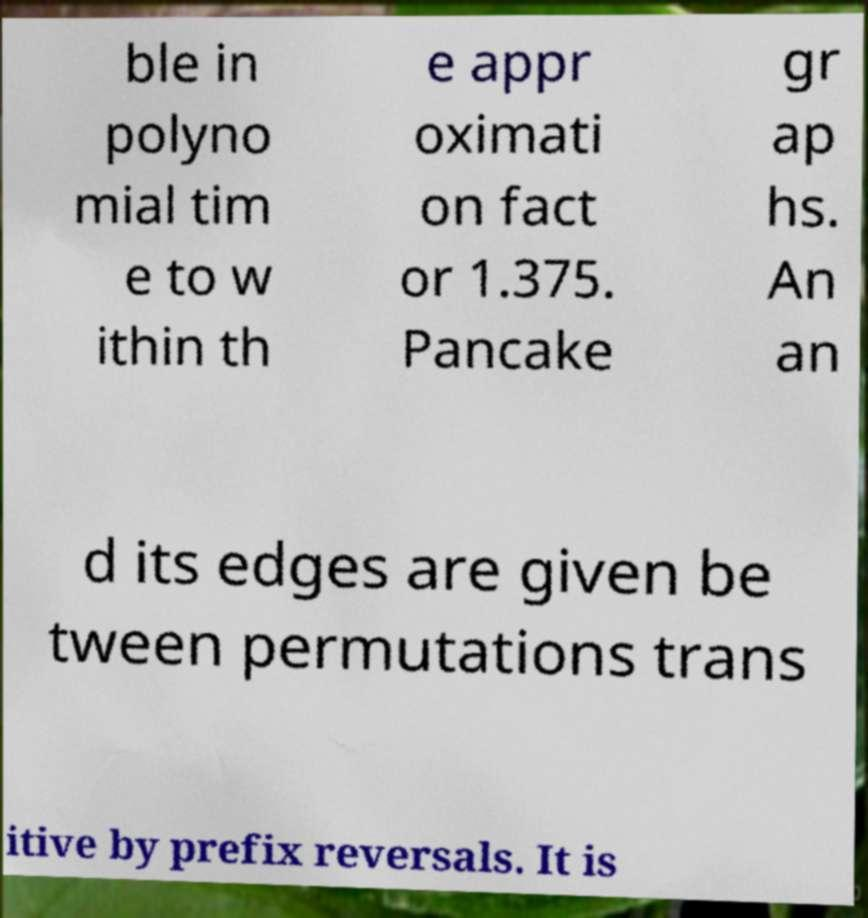Can you read and provide the text displayed in the image?This photo seems to have some interesting text. Can you extract and type it out for me? ble in polyno mial tim e to w ithin th e appr oximati on fact or 1.375. Pancake gr ap hs. An an d its edges are given be tween permutations trans itive by prefix reversals. It is 